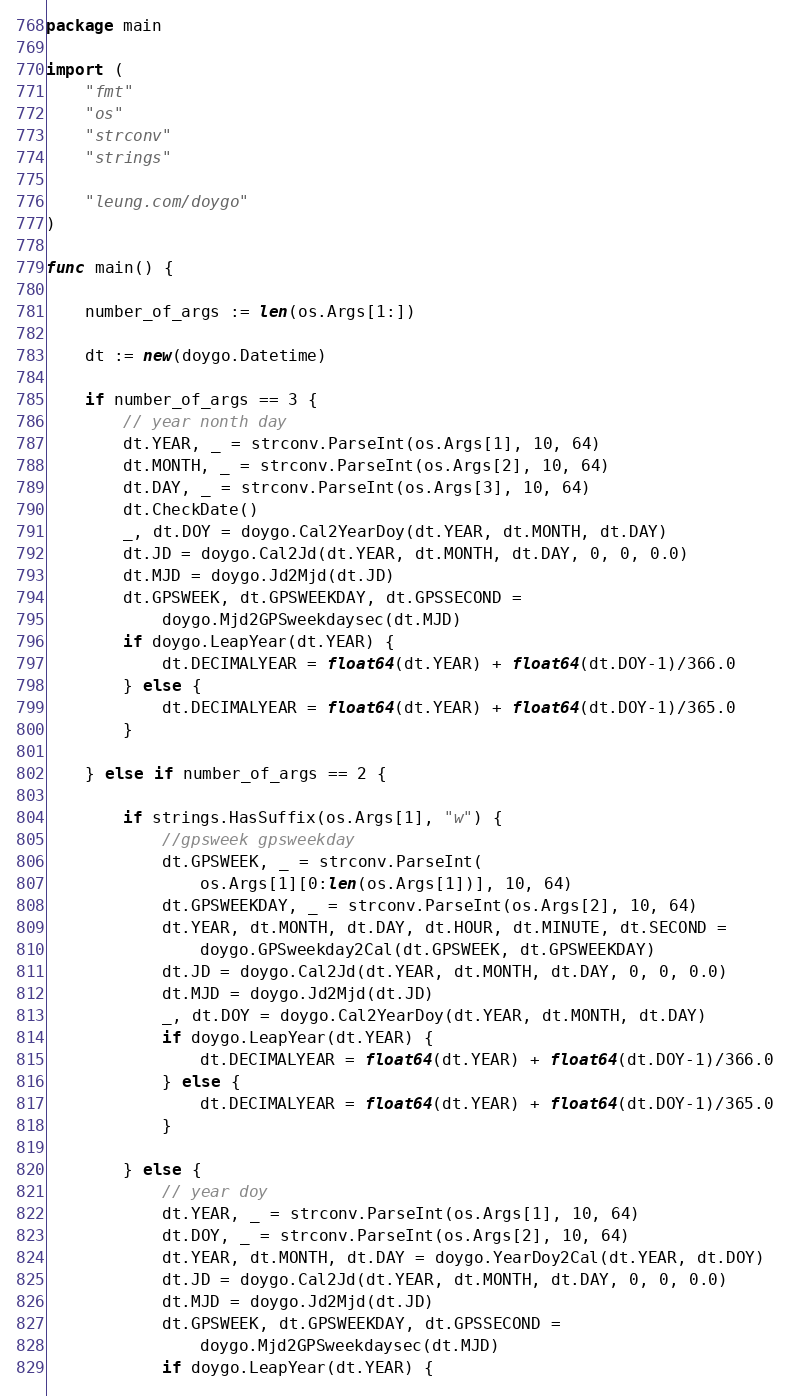<code> <loc_0><loc_0><loc_500><loc_500><_Go_>package main

import (
	"fmt"
	"os"
	"strconv"
	"strings"

	"leung.com/doygo"
)

func main() {

	number_of_args := len(os.Args[1:])

	dt := new(doygo.Datetime)

	if number_of_args == 3 {
		// year nonth day
		dt.YEAR, _ = strconv.ParseInt(os.Args[1], 10, 64)
		dt.MONTH, _ = strconv.ParseInt(os.Args[2], 10, 64)
		dt.DAY, _ = strconv.ParseInt(os.Args[3], 10, 64)
		dt.CheckDate()
		_, dt.DOY = doygo.Cal2YearDoy(dt.YEAR, dt.MONTH, dt.DAY)
		dt.JD = doygo.Cal2Jd(dt.YEAR, dt.MONTH, dt.DAY, 0, 0, 0.0)
		dt.MJD = doygo.Jd2Mjd(dt.JD)
		dt.GPSWEEK, dt.GPSWEEKDAY, dt.GPSSECOND =
			doygo.Mjd2GPSweekdaysec(dt.MJD)
		if doygo.LeapYear(dt.YEAR) {
			dt.DECIMALYEAR = float64(dt.YEAR) + float64(dt.DOY-1)/366.0
		} else {
			dt.DECIMALYEAR = float64(dt.YEAR) + float64(dt.DOY-1)/365.0
		}

	} else if number_of_args == 2 {

		if strings.HasSuffix(os.Args[1], "w") {
			//gpsweek gpsweekday
			dt.GPSWEEK, _ = strconv.ParseInt(
				os.Args[1][0:len(os.Args[1])], 10, 64)
			dt.GPSWEEKDAY, _ = strconv.ParseInt(os.Args[2], 10, 64)
			dt.YEAR, dt.MONTH, dt.DAY, dt.HOUR, dt.MINUTE, dt.SECOND =
				doygo.GPSweekday2Cal(dt.GPSWEEK, dt.GPSWEEKDAY)
			dt.JD = doygo.Cal2Jd(dt.YEAR, dt.MONTH, dt.DAY, 0, 0, 0.0)
			dt.MJD = doygo.Jd2Mjd(dt.JD)
			_, dt.DOY = doygo.Cal2YearDoy(dt.YEAR, dt.MONTH, dt.DAY)
			if doygo.LeapYear(dt.YEAR) {
				dt.DECIMALYEAR = float64(dt.YEAR) + float64(dt.DOY-1)/366.0
			} else {
				dt.DECIMALYEAR = float64(dt.YEAR) + float64(dt.DOY-1)/365.0
			}

		} else {
			// year doy
			dt.YEAR, _ = strconv.ParseInt(os.Args[1], 10, 64)
			dt.DOY, _ = strconv.ParseInt(os.Args[2], 10, 64)
			dt.YEAR, dt.MONTH, dt.DAY = doygo.YearDoy2Cal(dt.YEAR, dt.DOY)
			dt.JD = doygo.Cal2Jd(dt.YEAR, dt.MONTH, dt.DAY, 0, 0, 0.0)
			dt.MJD = doygo.Jd2Mjd(dt.JD)
			dt.GPSWEEK, dt.GPSWEEKDAY, dt.GPSSECOND =
				doygo.Mjd2GPSweekdaysec(dt.MJD)
			if doygo.LeapYear(dt.YEAR) {</code> 